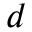<formula> <loc_0><loc_0><loc_500><loc_500>d</formula> 